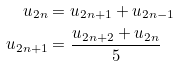Convert formula to latex. <formula><loc_0><loc_0><loc_500><loc_500>u _ { 2 n } & = u _ { 2 n + 1 } + u _ { 2 n - 1 } \\ u _ { 2 n + 1 } & = \frac { u _ { 2 n + 2 } + u _ { 2 n } } { 5 }</formula> 